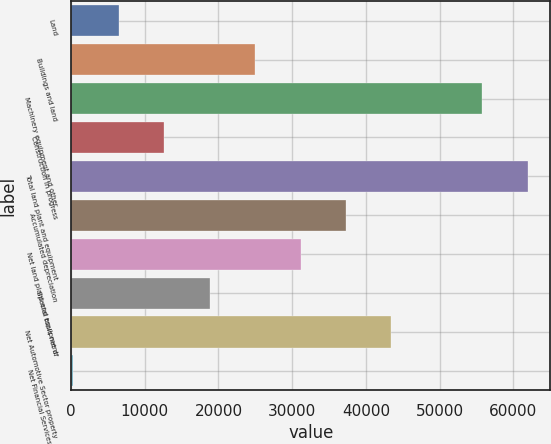Convert chart to OTSL. <chart><loc_0><loc_0><loc_500><loc_500><bar_chart><fcel>Land<fcel>Buildings and land<fcel>Machinery equipment and other<fcel>Construction in progress<fcel>Total land plant and equipment<fcel>Accumulated depreciation<fcel>Net land plant and equipment<fcel>Special tools net of<fcel>Net Automotive Sector property<fcel>Net Financial Services Sector<nl><fcel>6489.8<fcel>24975.2<fcel>55784.2<fcel>12651.6<fcel>61946<fcel>37298.8<fcel>31137<fcel>18813.4<fcel>43460.6<fcel>328<nl></chart> 